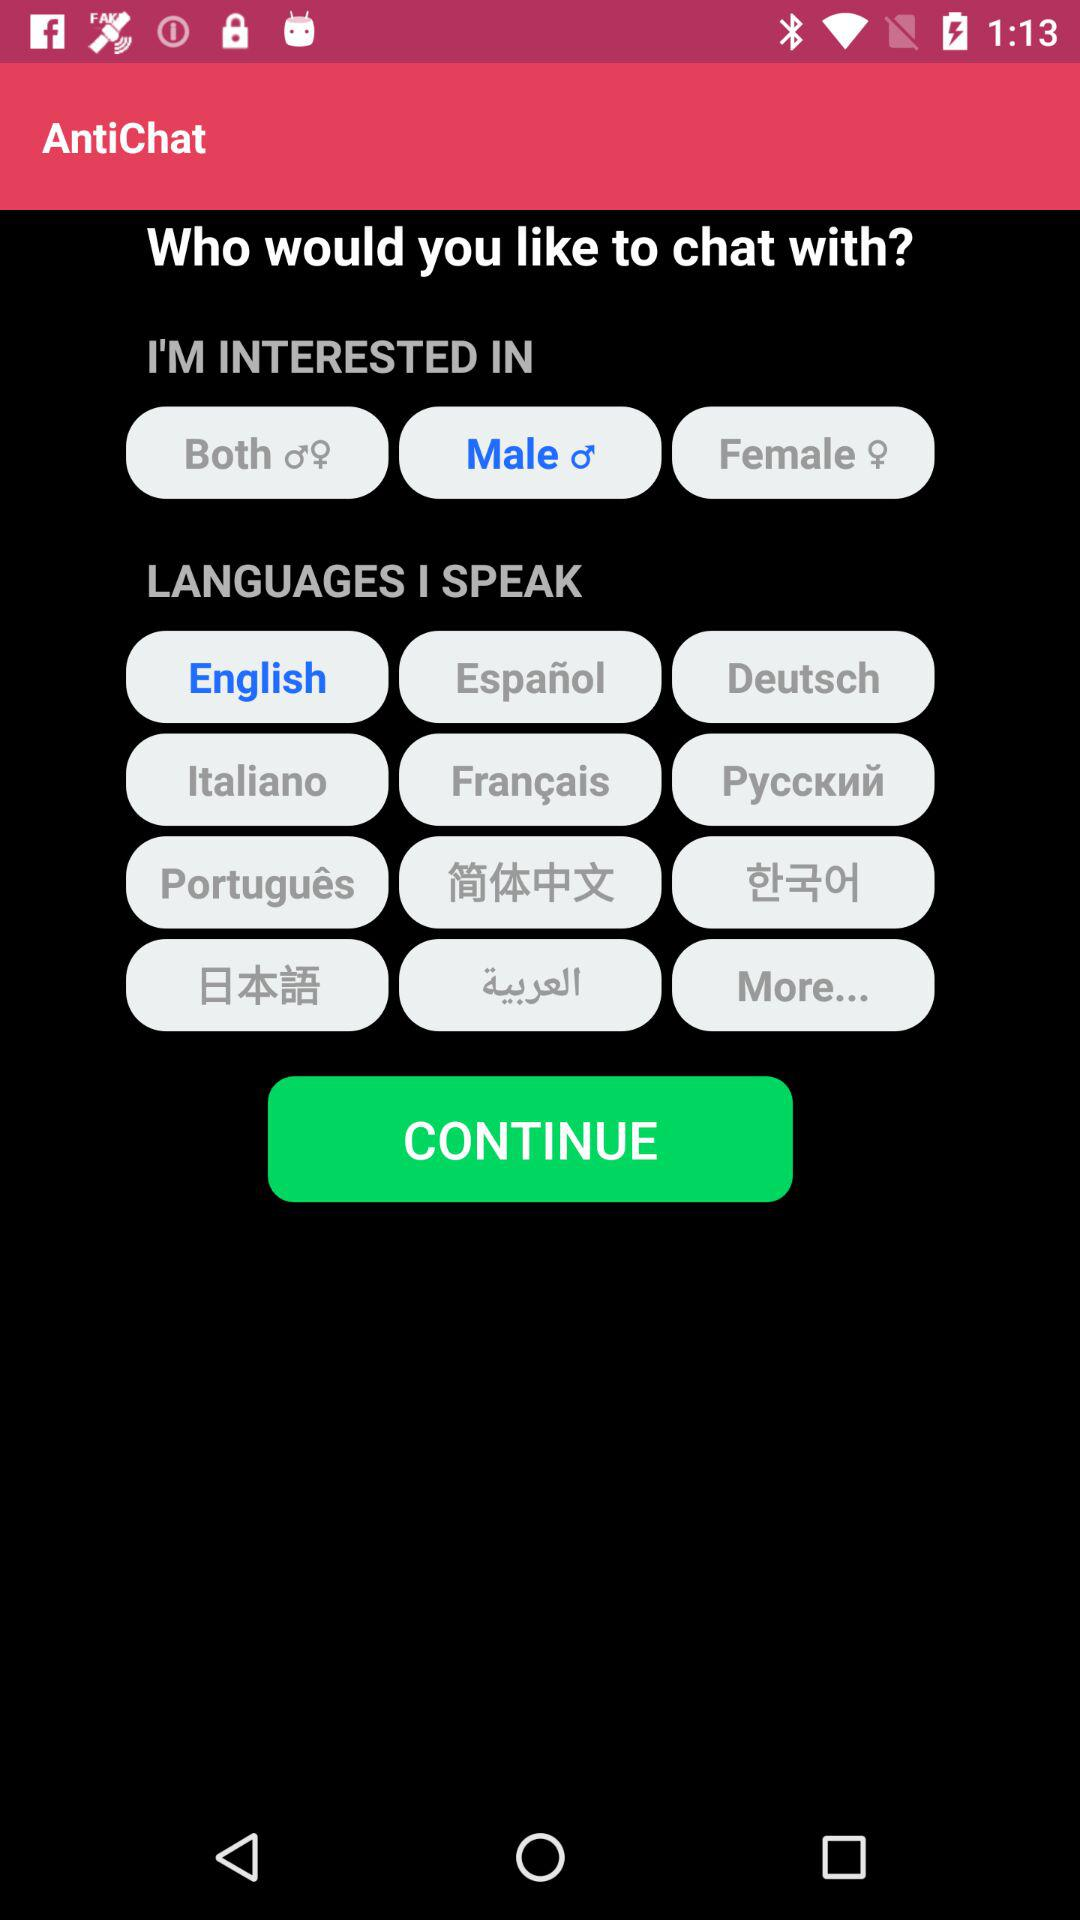What is the selected language? The selected language is English. 